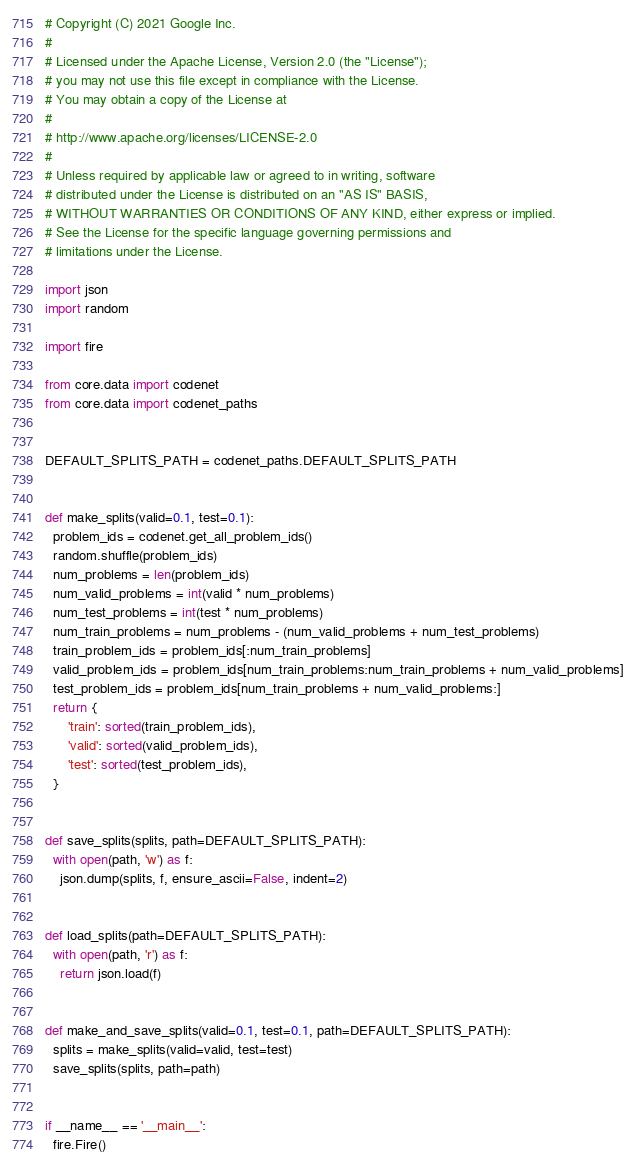<code> <loc_0><loc_0><loc_500><loc_500><_Python_># Copyright (C) 2021 Google Inc.
#
# Licensed under the Apache License, Version 2.0 (the "License");
# you may not use this file except in compliance with the License.
# You may obtain a copy of the License at
#
# http://www.apache.org/licenses/LICENSE-2.0
#
# Unless required by applicable law or agreed to in writing, software
# distributed under the License is distributed on an "AS IS" BASIS,
# WITHOUT WARRANTIES OR CONDITIONS OF ANY KIND, either express or implied.
# See the License for the specific language governing permissions and
# limitations under the License.

import json
import random

import fire

from core.data import codenet
from core.data import codenet_paths


DEFAULT_SPLITS_PATH = codenet_paths.DEFAULT_SPLITS_PATH


def make_splits(valid=0.1, test=0.1):
  problem_ids = codenet.get_all_problem_ids()
  random.shuffle(problem_ids)
  num_problems = len(problem_ids)
  num_valid_problems = int(valid * num_problems)
  num_test_problems = int(test * num_problems)
  num_train_problems = num_problems - (num_valid_problems + num_test_problems)
  train_problem_ids = problem_ids[:num_train_problems]
  valid_problem_ids = problem_ids[num_train_problems:num_train_problems + num_valid_problems]
  test_problem_ids = problem_ids[num_train_problems + num_valid_problems:]
  return {
      'train': sorted(train_problem_ids),
      'valid': sorted(valid_problem_ids),
      'test': sorted(test_problem_ids),
  }


def save_splits(splits, path=DEFAULT_SPLITS_PATH):
  with open(path, 'w') as f:
    json.dump(splits, f, ensure_ascii=False, indent=2)


def load_splits(path=DEFAULT_SPLITS_PATH):
  with open(path, 'r') as f:
    return json.load(f)


def make_and_save_splits(valid=0.1, test=0.1, path=DEFAULT_SPLITS_PATH):
  splits = make_splits(valid=valid, test=test)
  save_splits(splits, path=path)


if __name__ == '__main__':
  fire.Fire()
</code> 